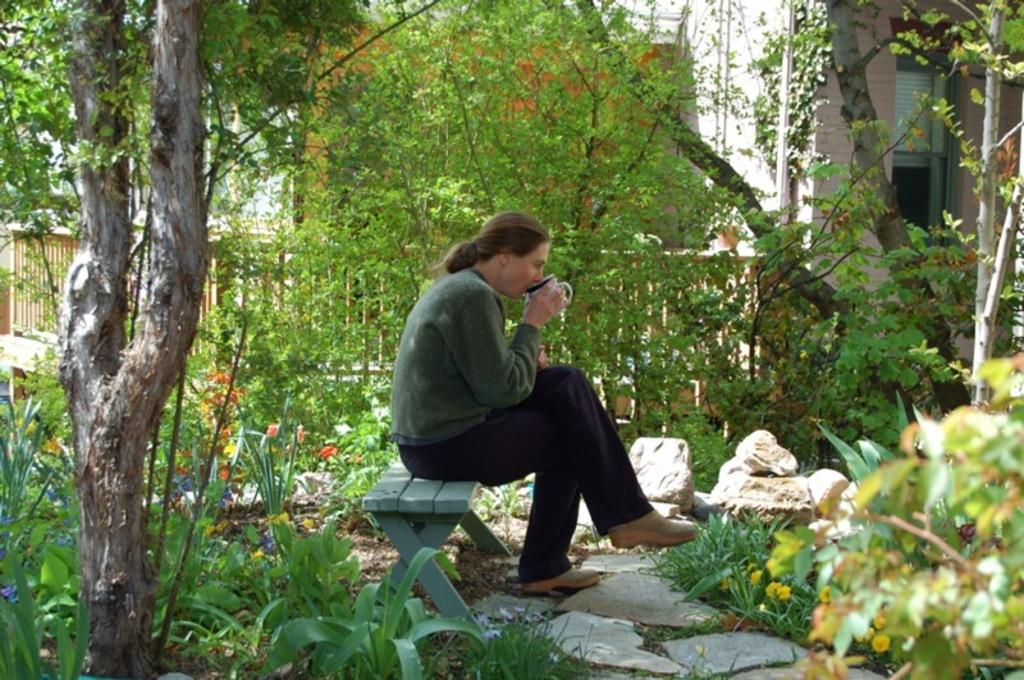What is the person in the image doing? The person is holding a cup in the image. Where is the person sitting? The person is sitting on a bench in the image. What can be seen in the background of the image? There are trees, a building, fencing, and stones visible in the background. What type of thrill can be experienced by the person in the image? There is no indication in the image that the person is experiencing any thrill. What is the texture of the person's chin in the image? There is no information about the person's chin in the image, so it cannot be determined. 